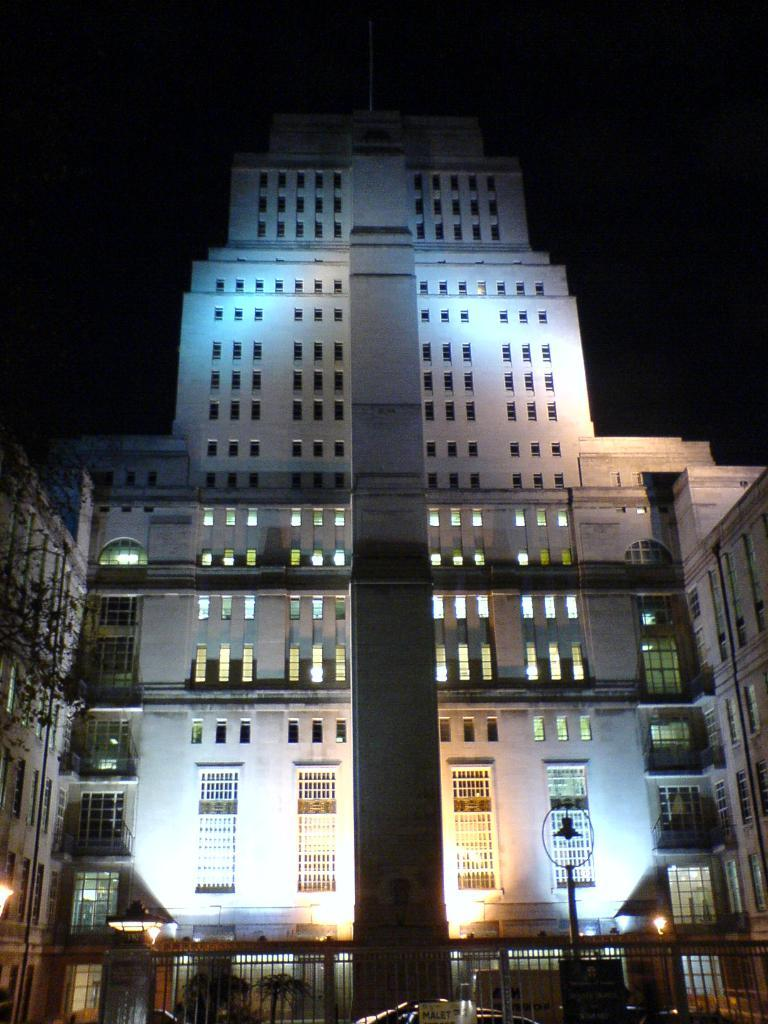What is the main structure in the center of the image? There is a building in the center of the image. What other object is also located in the center of the image? There is a tree in the center of the image. What type of vertical structure can be seen in the image? There is a pole in the image. What type of barrier is present in the image? There is a fence in the image. What type of transportation is visible in the image? There are vehicles in the image. How would you describe the lighting in the image? The background of the image is dark. How many brothers are riding bikes in the image? There are no brothers or bikes present in the image. What route are the vehicles taking in the image? The image does not provide information about the vehicles' routes. 